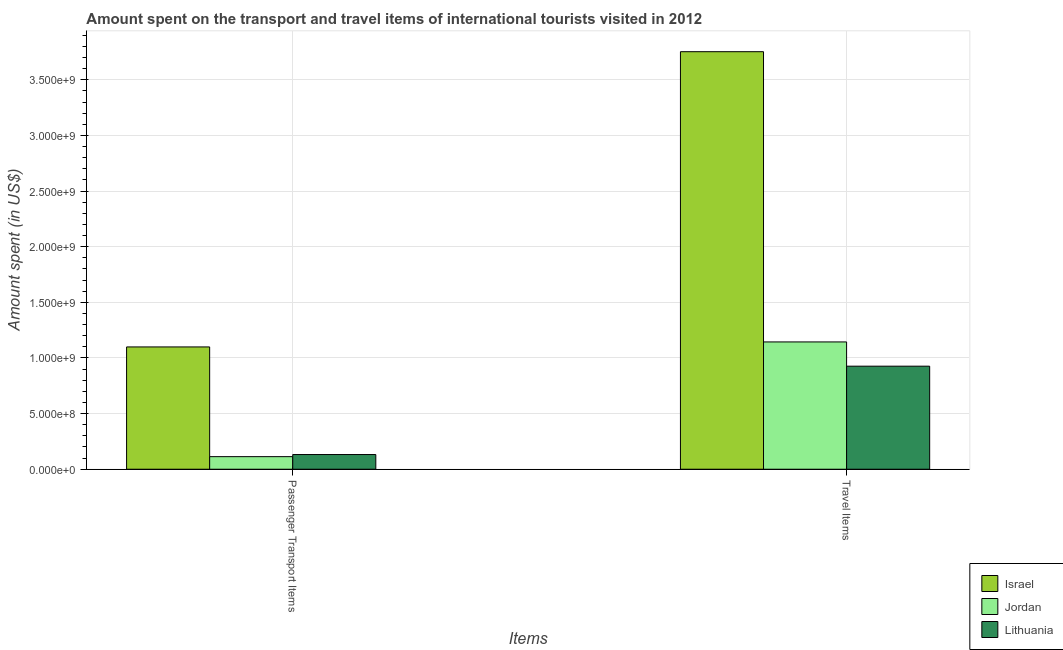How many different coloured bars are there?
Provide a succinct answer. 3. Are the number of bars per tick equal to the number of legend labels?
Offer a terse response. Yes. How many bars are there on the 2nd tick from the left?
Your answer should be very brief. 3. What is the label of the 2nd group of bars from the left?
Your response must be concise. Travel Items. What is the amount spent in travel items in Israel?
Your answer should be compact. 3.75e+09. Across all countries, what is the maximum amount spent on passenger transport items?
Offer a terse response. 1.10e+09. Across all countries, what is the minimum amount spent on passenger transport items?
Make the answer very short. 1.13e+08. In which country was the amount spent in travel items minimum?
Give a very brief answer. Lithuania. What is the total amount spent on passenger transport items in the graph?
Ensure brevity in your answer.  1.34e+09. What is the difference between the amount spent on passenger transport items in Israel and that in Jordan?
Provide a short and direct response. 9.86e+08. What is the difference between the amount spent in travel items in Lithuania and the amount spent on passenger transport items in Jordan?
Provide a short and direct response. 8.13e+08. What is the average amount spent in travel items per country?
Keep it short and to the point. 1.94e+09. What is the difference between the amount spent in travel items and amount spent on passenger transport items in Lithuania?
Offer a very short reply. 7.94e+08. What is the ratio of the amount spent in travel items in Lithuania to that in Israel?
Ensure brevity in your answer.  0.25. Is the amount spent on passenger transport items in Lithuania less than that in Israel?
Offer a terse response. Yes. In how many countries, is the amount spent in travel items greater than the average amount spent in travel items taken over all countries?
Provide a short and direct response. 1. What does the 2nd bar from the left in Passenger Transport Items represents?
Offer a terse response. Jordan. What does the 3rd bar from the right in Travel Items represents?
Make the answer very short. Israel. What is the difference between two consecutive major ticks on the Y-axis?
Give a very brief answer. 5.00e+08. Are the values on the major ticks of Y-axis written in scientific E-notation?
Your answer should be very brief. Yes. Does the graph contain any zero values?
Offer a terse response. No. How many legend labels are there?
Your response must be concise. 3. How are the legend labels stacked?
Make the answer very short. Vertical. What is the title of the graph?
Provide a short and direct response. Amount spent on the transport and travel items of international tourists visited in 2012. Does "Korea (Republic)" appear as one of the legend labels in the graph?
Your answer should be compact. No. What is the label or title of the X-axis?
Your response must be concise. Items. What is the label or title of the Y-axis?
Make the answer very short. Amount spent (in US$). What is the Amount spent (in US$) of Israel in Passenger Transport Items?
Provide a short and direct response. 1.10e+09. What is the Amount spent (in US$) of Jordan in Passenger Transport Items?
Your response must be concise. 1.13e+08. What is the Amount spent (in US$) of Lithuania in Passenger Transport Items?
Provide a succinct answer. 1.32e+08. What is the Amount spent (in US$) in Israel in Travel Items?
Your answer should be compact. 3.75e+09. What is the Amount spent (in US$) of Jordan in Travel Items?
Your answer should be very brief. 1.14e+09. What is the Amount spent (in US$) of Lithuania in Travel Items?
Keep it short and to the point. 9.26e+08. Across all Items, what is the maximum Amount spent (in US$) of Israel?
Your response must be concise. 3.75e+09. Across all Items, what is the maximum Amount spent (in US$) of Jordan?
Keep it short and to the point. 1.14e+09. Across all Items, what is the maximum Amount spent (in US$) in Lithuania?
Offer a terse response. 9.26e+08. Across all Items, what is the minimum Amount spent (in US$) of Israel?
Your answer should be very brief. 1.10e+09. Across all Items, what is the minimum Amount spent (in US$) in Jordan?
Keep it short and to the point. 1.13e+08. Across all Items, what is the minimum Amount spent (in US$) in Lithuania?
Your answer should be very brief. 1.32e+08. What is the total Amount spent (in US$) of Israel in the graph?
Give a very brief answer. 4.85e+09. What is the total Amount spent (in US$) in Jordan in the graph?
Ensure brevity in your answer.  1.26e+09. What is the total Amount spent (in US$) of Lithuania in the graph?
Provide a short and direct response. 1.06e+09. What is the difference between the Amount spent (in US$) of Israel in Passenger Transport Items and that in Travel Items?
Your answer should be compact. -2.65e+09. What is the difference between the Amount spent (in US$) in Jordan in Passenger Transport Items and that in Travel Items?
Give a very brief answer. -1.03e+09. What is the difference between the Amount spent (in US$) in Lithuania in Passenger Transport Items and that in Travel Items?
Give a very brief answer. -7.94e+08. What is the difference between the Amount spent (in US$) of Israel in Passenger Transport Items and the Amount spent (in US$) of Jordan in Travel Items?
Your answer should be very brief. -4.50e+07. What is the difference between the Amount spent (in US$) of Israel in Passenger Transport Items and the Amount spent (in US$) of Lithuania in Travel Items?
Provide a succinct answer. 1.73e+08. What is the difference between the Amount spent (in US$) of Jordan in Passenger Transport Items and the Amount spent (in US$) of Lithuania in Travel Items?
Ensure brevity in your answer.  -8.13e+08. What is the average Amount spent (in US$) in Israel per Items?
Give a very brief answer. 2.43e+09. What is the average Amount spent (in US$) in Jordan per Items?
Ensure brevity in your answer.  6.28e+08. What is the average Amount spent (in US$) of Lithuania per Items?
Give a very brief answer. 5.29e+08. What is the difference between the Amount spent (in US$) in Israel and Amount spent (in US$) in Jordan in Passenger Transport Items?
Ensure brevity in your answer.  9.86e+08. What is the difference between the Amount spent (in US$) in Israel and Amount spent (in US$) in Lithuania in Passenger Transport Items?
Ensure brevity in your answer.  9.67e+08. What is the difference between the Amount spent (in US$) in Jordan and Amount spent (in US$) in Lithuania in Passenger Transport Items?
Provide a succinct answer. -1.90e+07. What is the difference between the Amount spent (in US$) in Israel and Amount spent (in US$) in Jordan in Travel Items?
Your response must be concise. 2.61e+09. What is the difference between the Amount spent (in US$) in Israel and Amount spent (in US$) in Lithuania in Travel Items?
Offer a very short reply. 2.83e+09. What is the difference between the Amount spent (in US$) of Jordan and Amount spent (in US$) of Lithuania in Travel Items?
Provide a short and direct response. 2.18e+08. What is the ratio of the Amount spent (in US$) in Israel in Passenger Transport Items to that in Travel Items?
Provide a short and direct response. 0.29. What is the ratio of the Amount spent (in US$) of Jordan in Passenger Transport Items to that in Travel Items?
Make the answer very short. 0.1. What is the ratio of the Amount spent (in US$) of Lithuania in Passenger Transport Items to that in Travel Items?
Give a very brief answer. 0.14. What is the difference between the highest and the second highest Amount spent (in US$) of Israel?
Keep it short and to the point. 2.65e+09. What is the difference between the highest and the second highest Amount spent (in US$) of Jordan?
Make the answer very short. 1.03e+09. What is the difference between the highest and the second highest Amount spent (in US$) of Lithuania?
Ensure brevity in your answer.  7.94e+08. What is the difference between the highest and the lowest Amount spent (in US$) of Israel?
Provide a succinct answer. 2.65e+09. What is the difference between the highest and the lowest Amount spent (in US$) of Jordan?
Make the answer very short. 1.03e+09. What is the difference between the highest and the lowest Amount spent (in US$) of Lithuania?
Ensure brevity in your answer.  7.94e+08. 